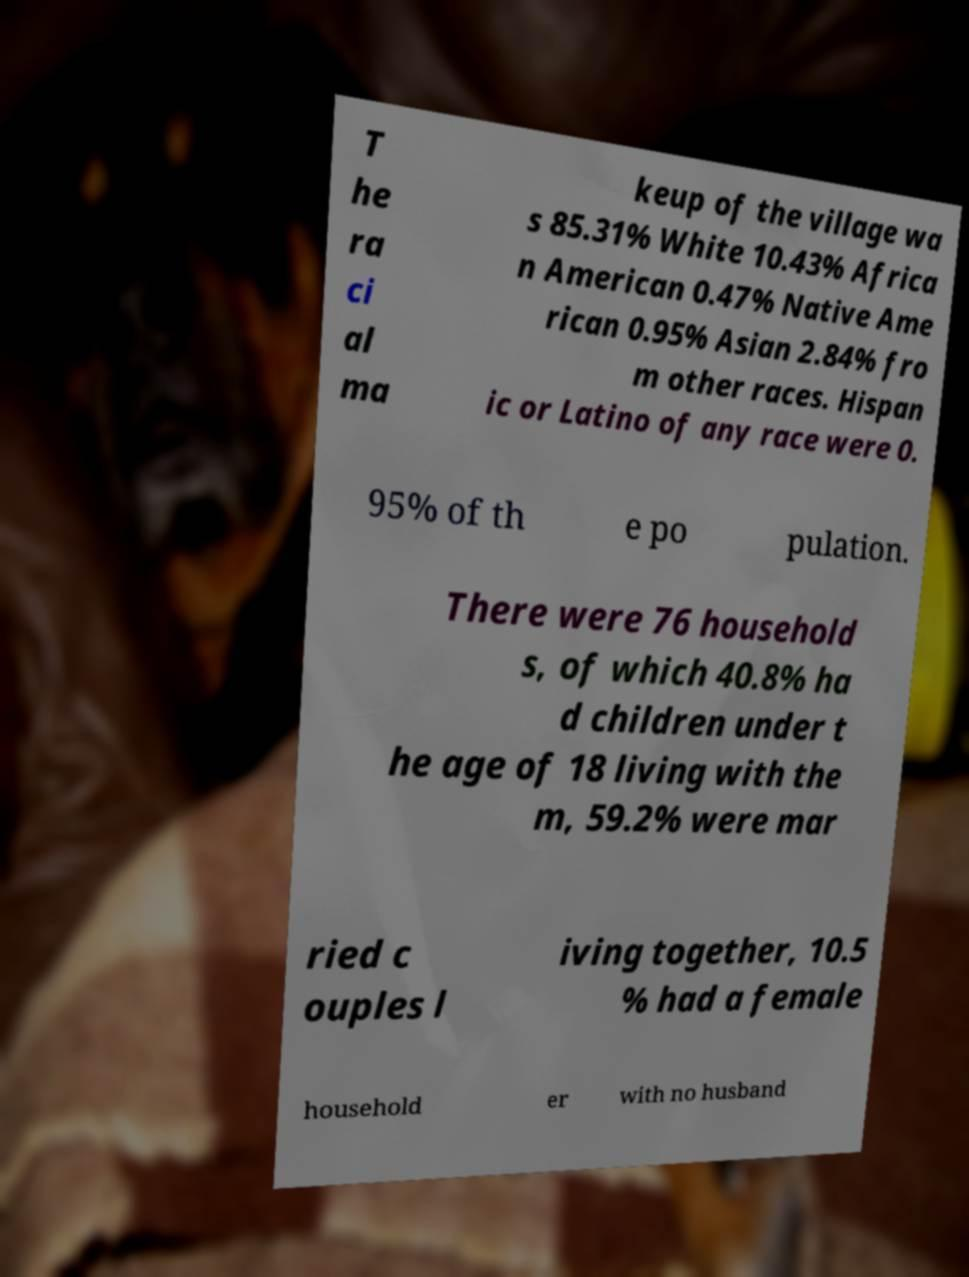Please read and relay the text visible in this image. What does it say? T he ra ci al ma keup of the village wa s 85.31% White 10.43% Africa n American 0.47% Native Ame rican 0.95% Asian 2.84% fro m other races. Hispan ic or Latino of any race were 0. 95% of th e po pulation. There were 76 household s, of which 40.8% ha d children under t he age of 18 living with the m, 59.2% were mar ried c ouples l iving together, 10.5 % had a female household er with no husband 